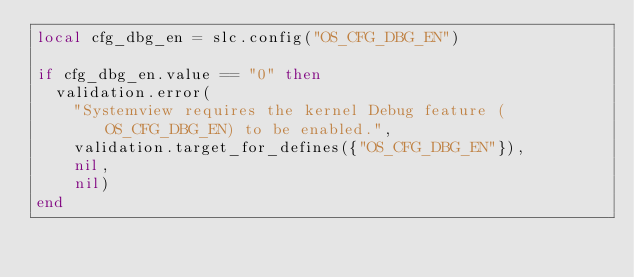Convert code to text. <code><loc_0><loc_0><loc_500><loc_500><_Lua_>local cfg_dbg_en = slc.config("OS_CFG_DBG_EN")

if cfg_dbg_en.value == "0" then
  validation.error(
    "Systemview requires the kernel Debug feature (OS_CFG_DBG_EN) to be enabled.",
    validation.target_for_defines({"OS_CFG_DBG_EN"}),
    nil,
    nil)
end</code> 